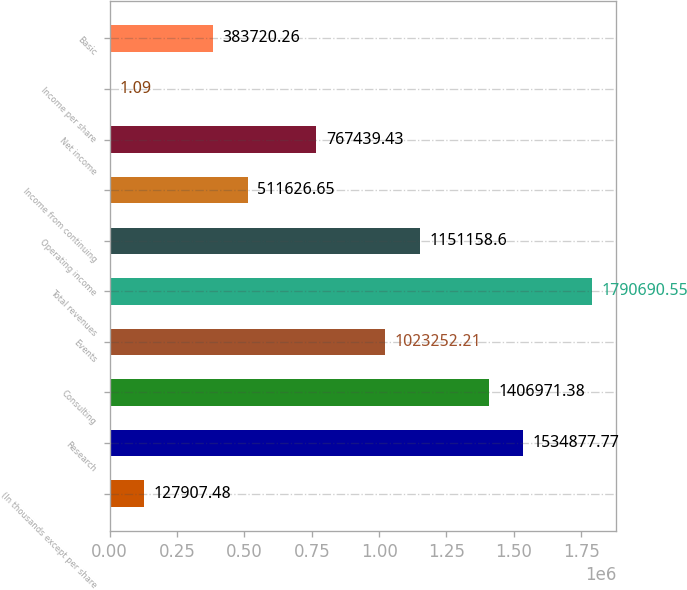Convert chart. <chart><loc_0><loc_0><loc_500><loc_500><bar_chart><fcel>(In thousands except per share<fcel>Research<fcel>Consulting<fcel>Events<fcel>Total revenues<fcel>Operating income<fcel>Income from continuing<fcel>Net income<fcel>Income per share<fcel>Basic<nl><fcel>127907<fcel>1.53488e+06<fcel>1.40697e+06<fcel>1.02325e+06<fcel>1.79069e+06<fcel>1.15116e+06<fcel>511627<fcel>767439<fcel>1.09<fcel>383720<nl></chart> 